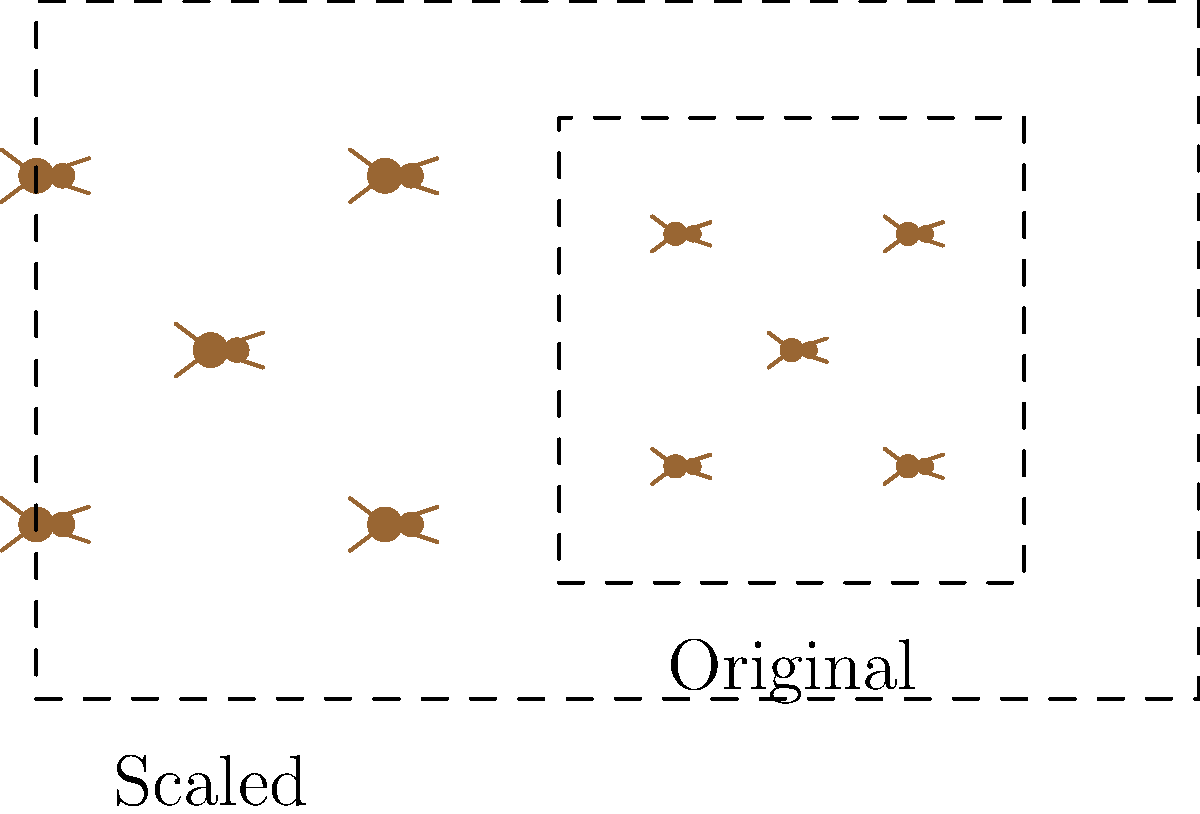In your ant colony diagram, you've decided to scale up the original layout to accommodate more ants. If the original diagram fits within a 4x4 unit square and the new scaled diagram fits within a 7x7 unit square, what is the scale factor used for the transformation? To find the scale factor, we need to compare the dimensions of the original and scaled diagrams:

1. Original diagram: 4x4 unit square
2. Scaled diagram: 7x7 unit square

To calculate the scale factor, we divide the new dimension by the original dimension:

$$ \text{Scale factor} = \frac{\text{New dimension}}{\text{Original dimension}} $$

$$ \text{Scale factor} = \frac{7}{4} = 1.75 $$

We can verify this by checking if multiplying the original dimension by 1.75 gives us the new dimension:

$$ 4 \times 1.75 = 7 $$

This confirms that the scale factor is indeed 1.75.
Answer: 1.75 